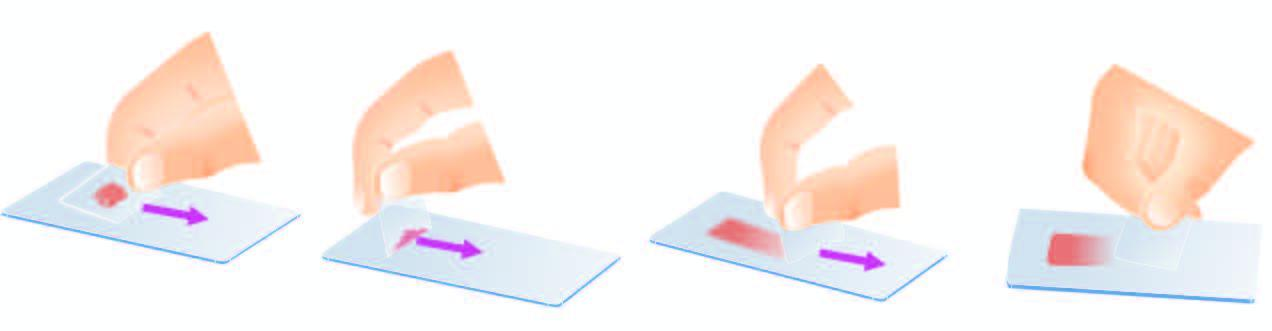re semisolid aspirates crush-smeared by flat pressure with cover slip or glass slide?
Answer the question using a single word or phrase. Yes 